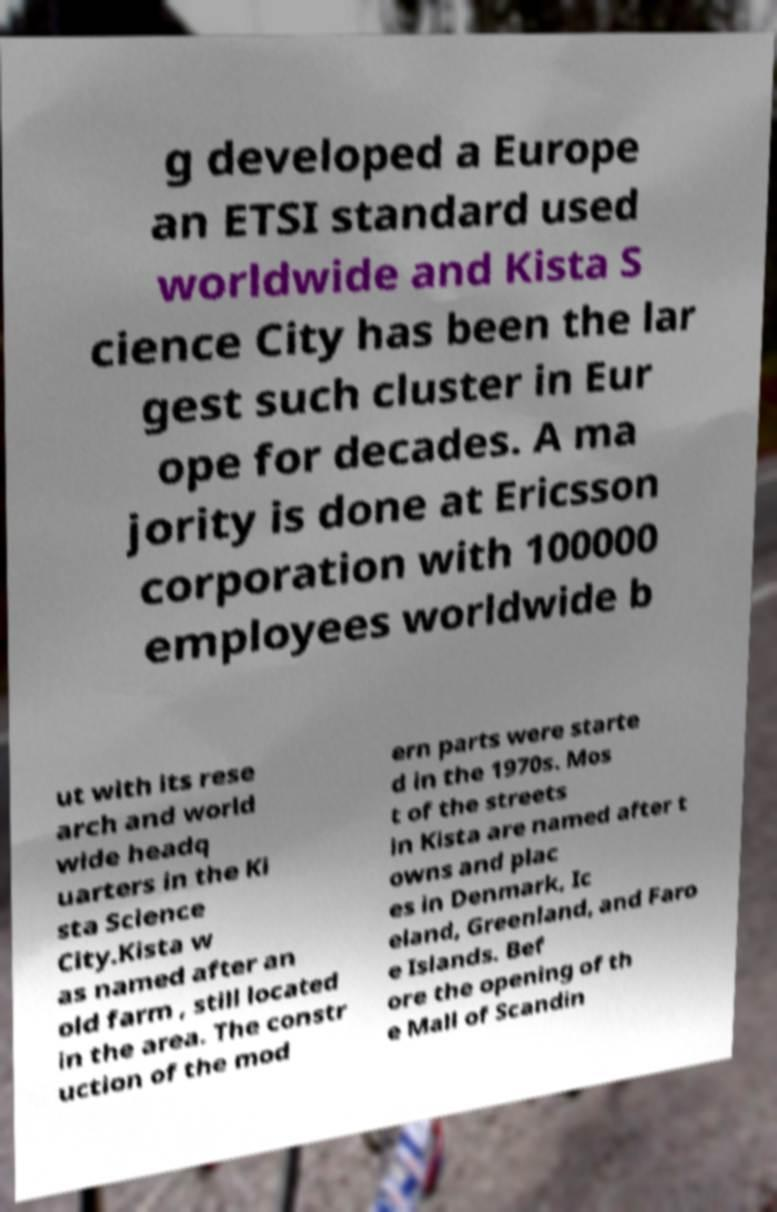What messages or text are displayed in this image? I need them in a readable, typed format. g developed a Europe an ETSI standard used worldwide and Kista S cience City has been the lar gest such cluster in Eur ope for decades. A ma jority is done at Ericsson corporation with 100000 employees worldwide b ut with its rese arch and world wide headq uarters in the Ki sta Science City.Kista w as named after an old farm , still located in the area. The constr uction of the mod ern parts were starte d in the 1970s. Mos t of the streets in Kista are named after t owns and plac es in Denmark, Ic eland, Greenland, and Faro e Islands. Bef ore the opening of th e Mall of Scandin 